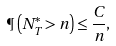Convert formula to latex. <formula><loc_0><loc_0><loc_500><loc_500>\P \left ( N ^ { * } _ { T } > n \right ) \leq \frac { C } { n } ,</formula> 